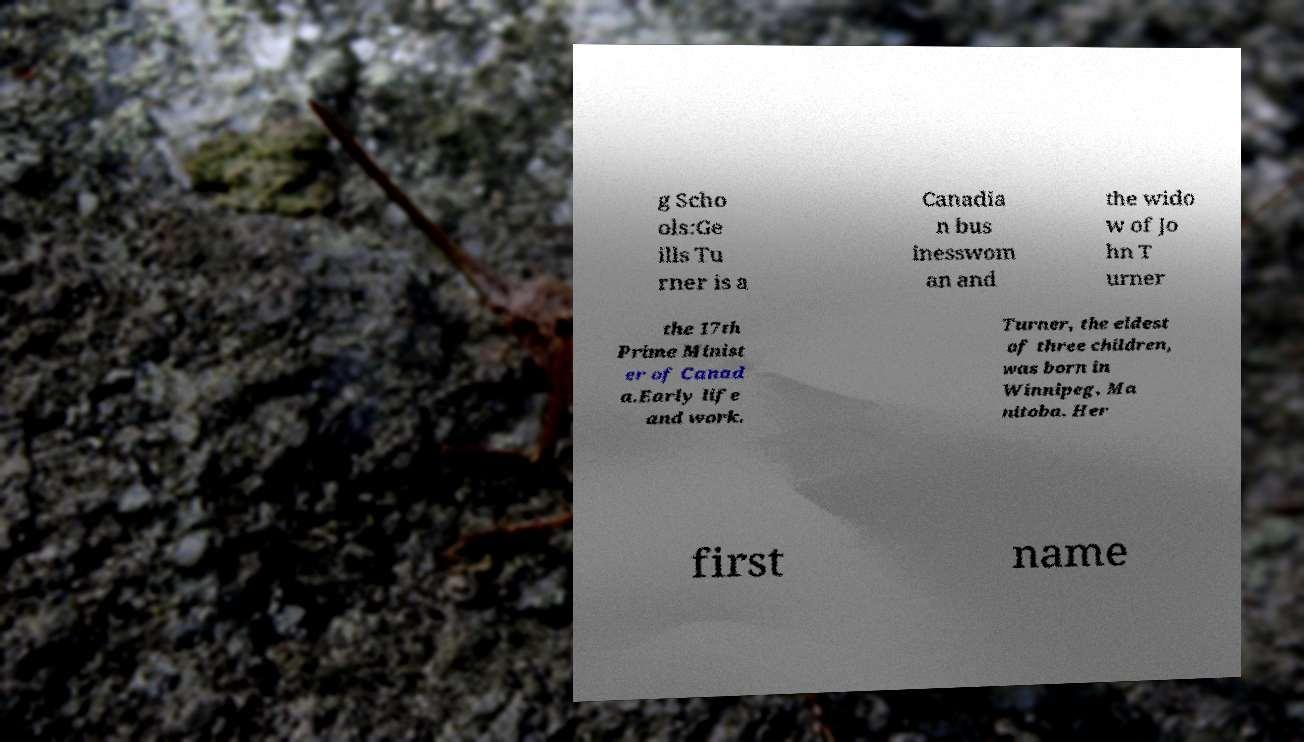Please read and relay the text visible in this image. What does it say? g Scho ols:Ge ills Tu rner is a Canadia n bus inesswom an and the wido w of Jo hn T urner the 17th Prime Minist er of Canad a.Early life and work. Turner, the eldest of three children, was born in Winnipeg, Ma nitoba. Her first name 